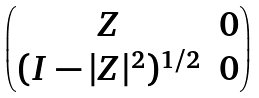<formula> <loc_0><loc_0><loc_500><loc_500>\begin{pmatrix} Z & 0 \\ ( I - | Z | ^ { 2 } ) ^ { 1 / 2 } & 0 \end{pmatrix}</formula> 